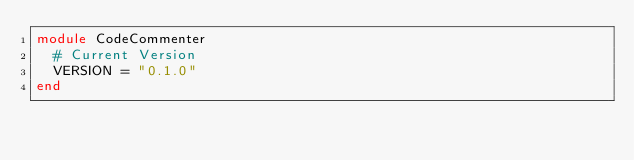<code> <loc_0><loc_0><loc_500><loc_500><_Ruby_>module CodeCommenter
  # Current Version
  VERSION = "0.1.0"
end
</code> 